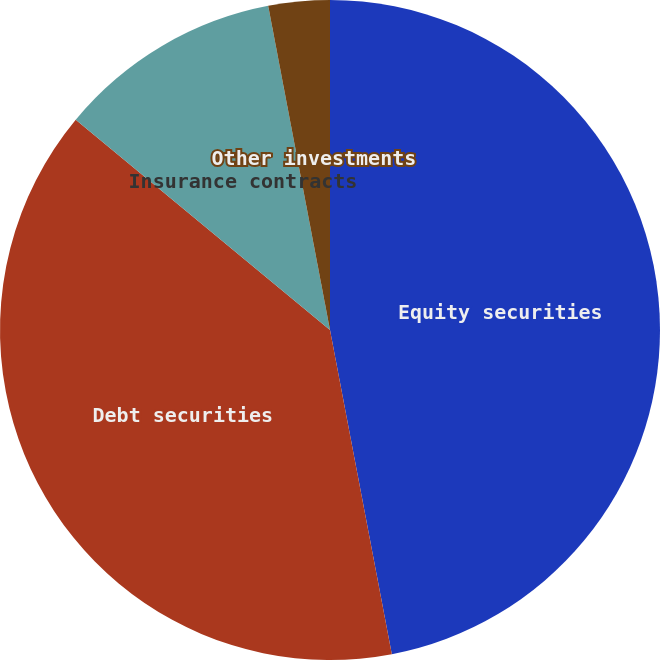Convert chart. <chart><loc_0><loc_0><loc_500><loc_500><pie_chart><fcel>Equity securities<fcel>Debt securities<fcel>Insurance contracts<fcel>Other investments<nl><fcel>47.0%<fcel>39.0%<fcel>11.0%<fcel>3.0%<nl></chart> 